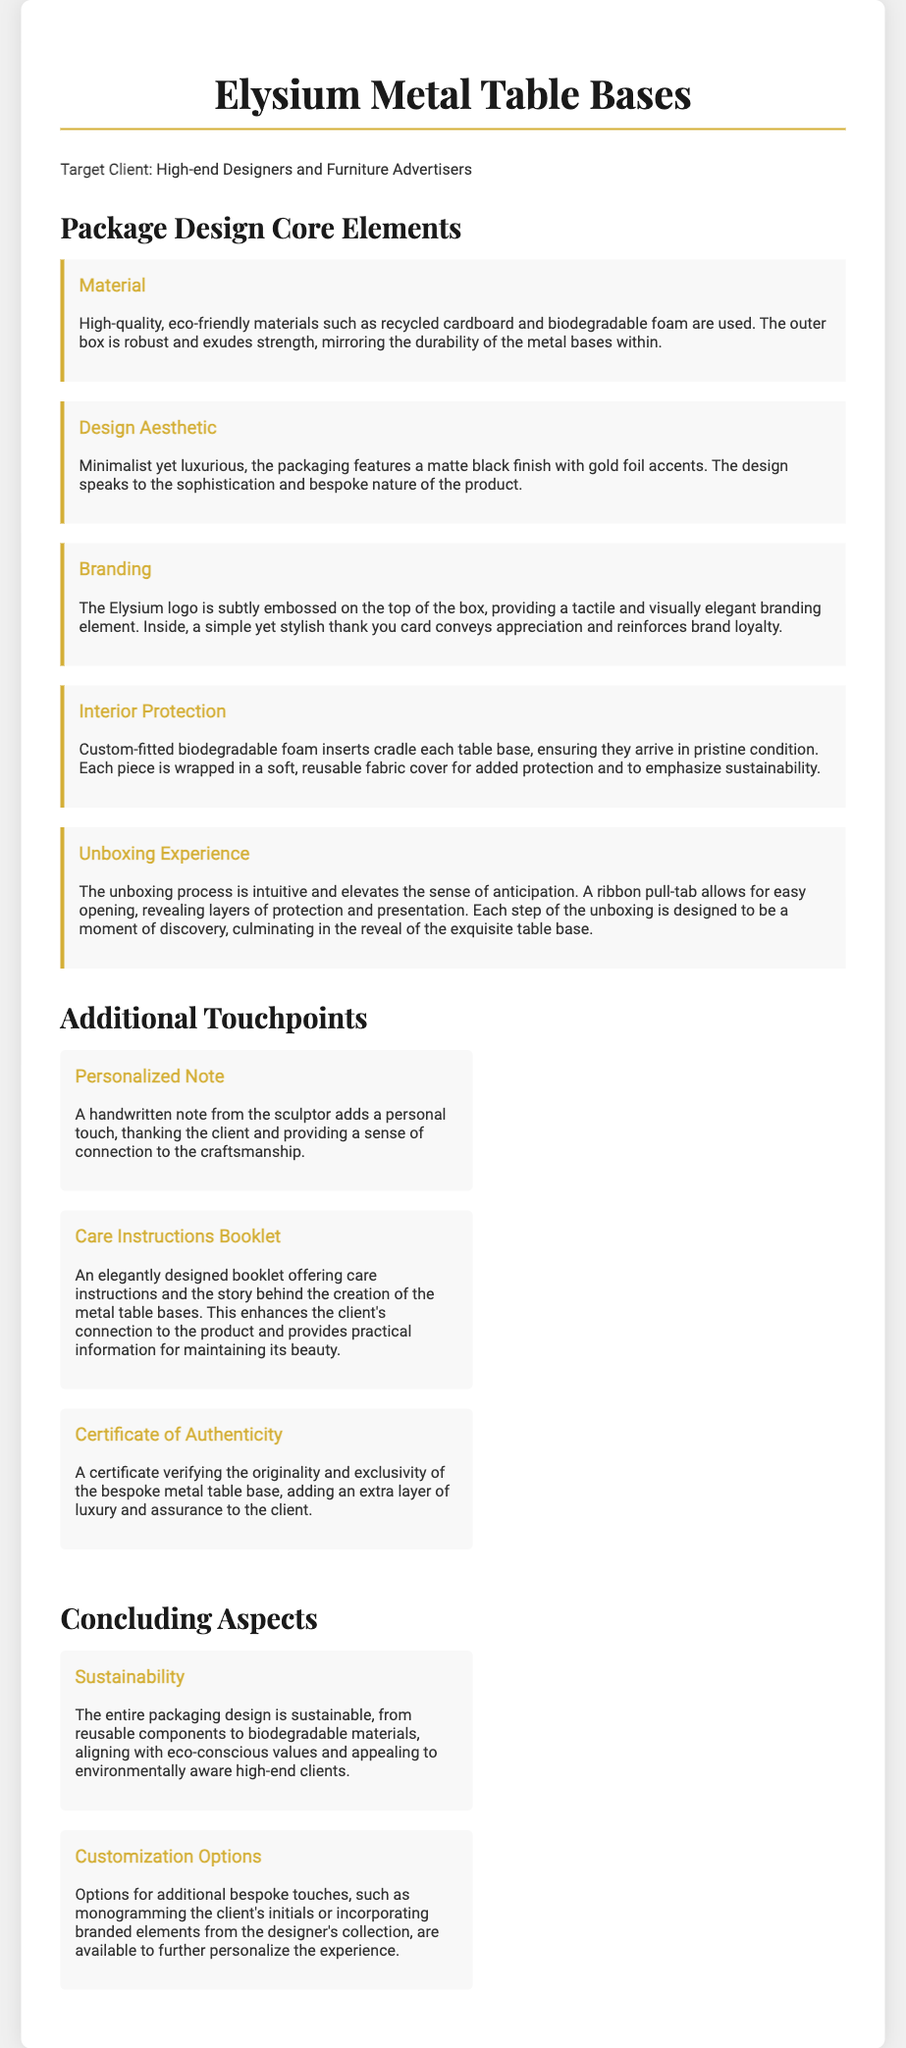what materials are used for packaging? The document states that high-quality, eco-friendly materials such as recycled cardboard and biodegradable foam are used for packaging.
Answer: recycled cardboard and biodegradable foam what is the main color scheme of the packaging? The design aesthetic mentions a matte black finish with gold foil accents, indicating the primary colors used.
Answer: matte black and gold what is included in the personalized touchpoints? The document describes a handwritten note from the sculptor as part of the personalized touchpoints.
Answer: handwritten note how does the packaging ensure the table bases arrive safely? The protection measures highlighted include custom-fitted biodegradable foam inserts and a soft, reusable fabric cover.
Answer: biodegradable foam inserts and fabric cover what type of booklet accompanies the metal table bases? The document mentions that an elegantly designed booklet offering care instructions is included.
Answer: care instructions booklet how is the unboxing experience designed? The unboxing experience is designed to be intuitive, with a ribbon pull-tab for easy opening, making it a moment of discovery.
Answer: intuitive with ribbon pull-tab what is the purpose of the certificate included in the packaging? The certificate verifies originality and exclusivity of the bespoke metal table base, adding luxury assurance.
Answer: to verify originality and exclusivity what aspect of packaging emphasizes sustainability? The entire packaging design is described as sustainable, highlighting the use of reusable components and biodegradable materials.
Answer: sustainable design how can the packaging be customized for clients? Options for additional bespoke touches such as monogramming initials are available for client customization.
Answer: monogramming initials 